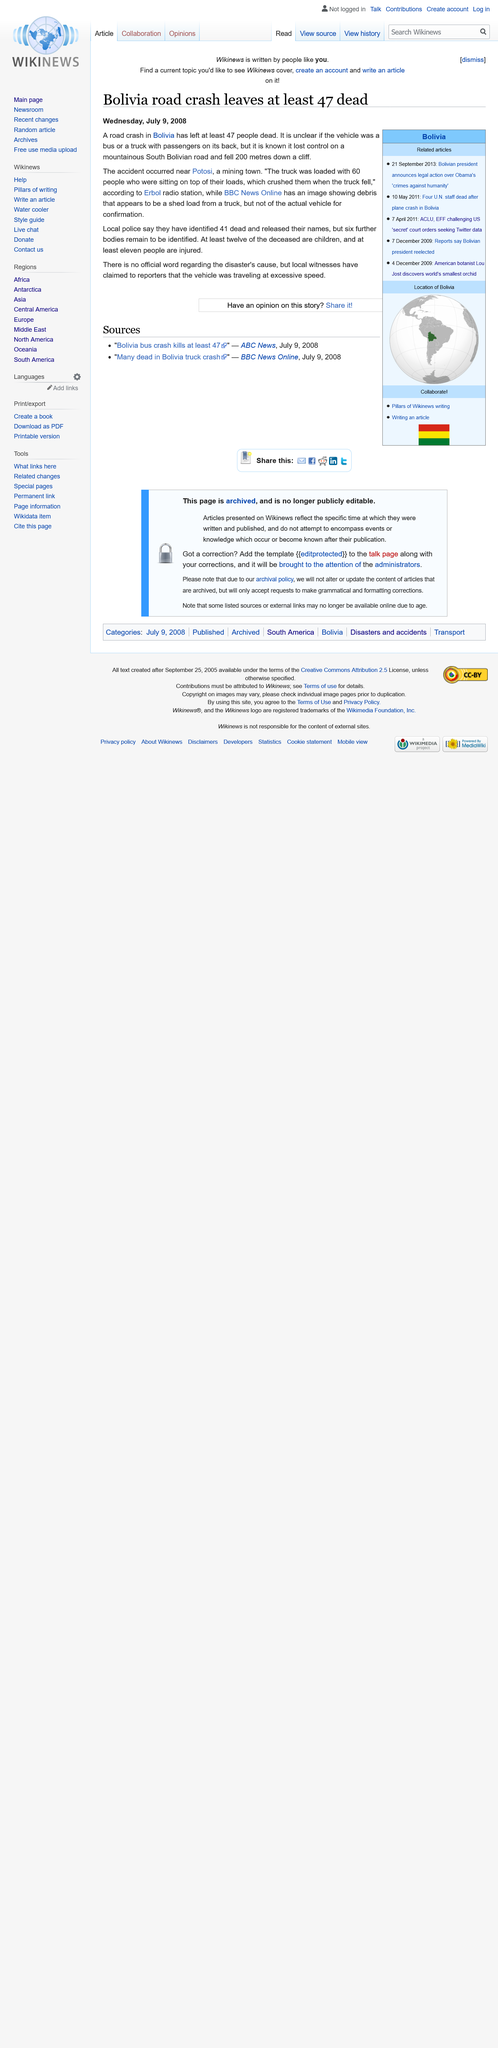Mention a couple of crucial points in this snapshot. In 2008, a road crash near Potosi, Bolivia resulted in at least 47 fatalities. The 2008 Potosi, Bolivia road crash resulted in the vehicle falling 200 meters down a cliff. On October 11, 2008, in Potosi, Bolivia, a road crash occurred, which was reported by Erbol radio station. 